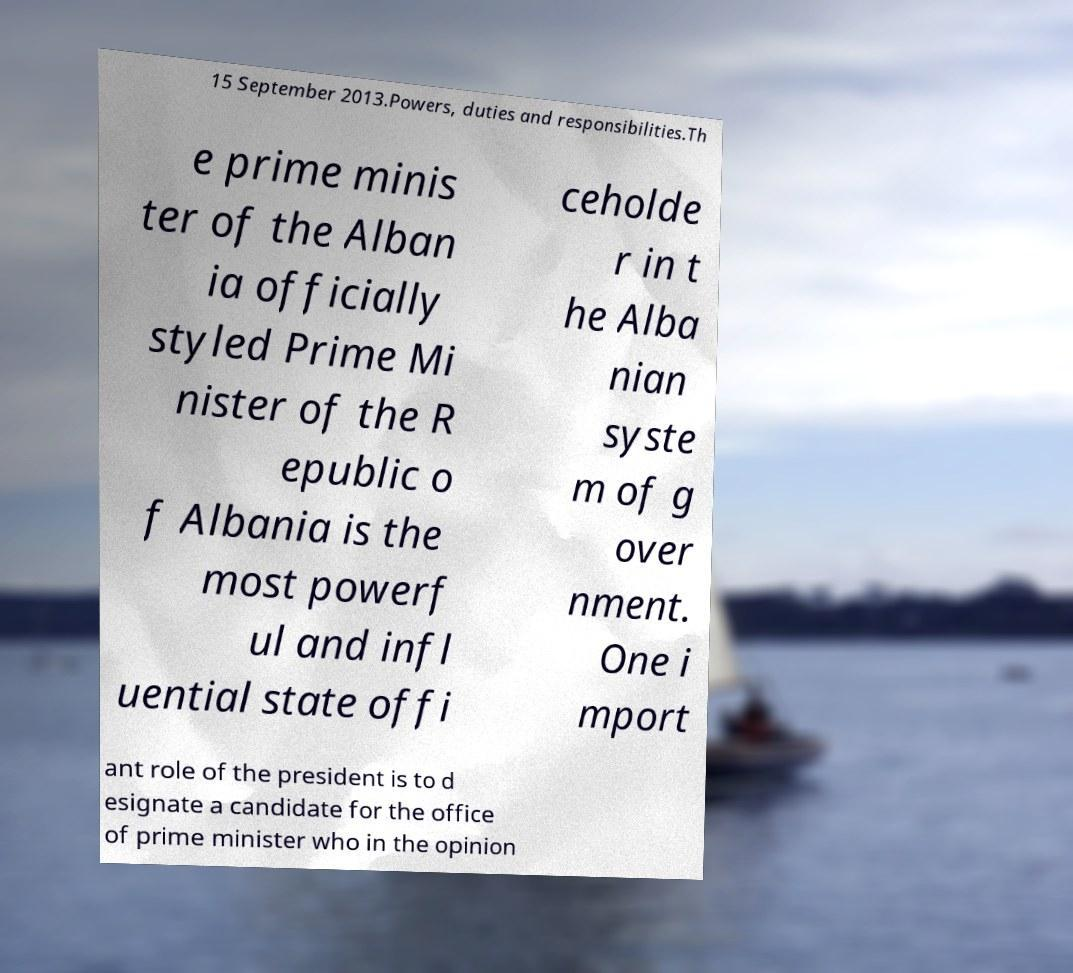Please read and relay the text visible in this image. What does it say? 15 September 2013.Powers, duties and responsibilities.Th e prime minis ter of the Alban ia officially styled Prime Mi nister of the R epublic o f Albania is the most powerf ul and infl uential state offi ceholde r in t he Alba nian syste m of g over nment. One i mport ant role of the president is to d esignate a candidate for the office of prime minister who in the opinion 